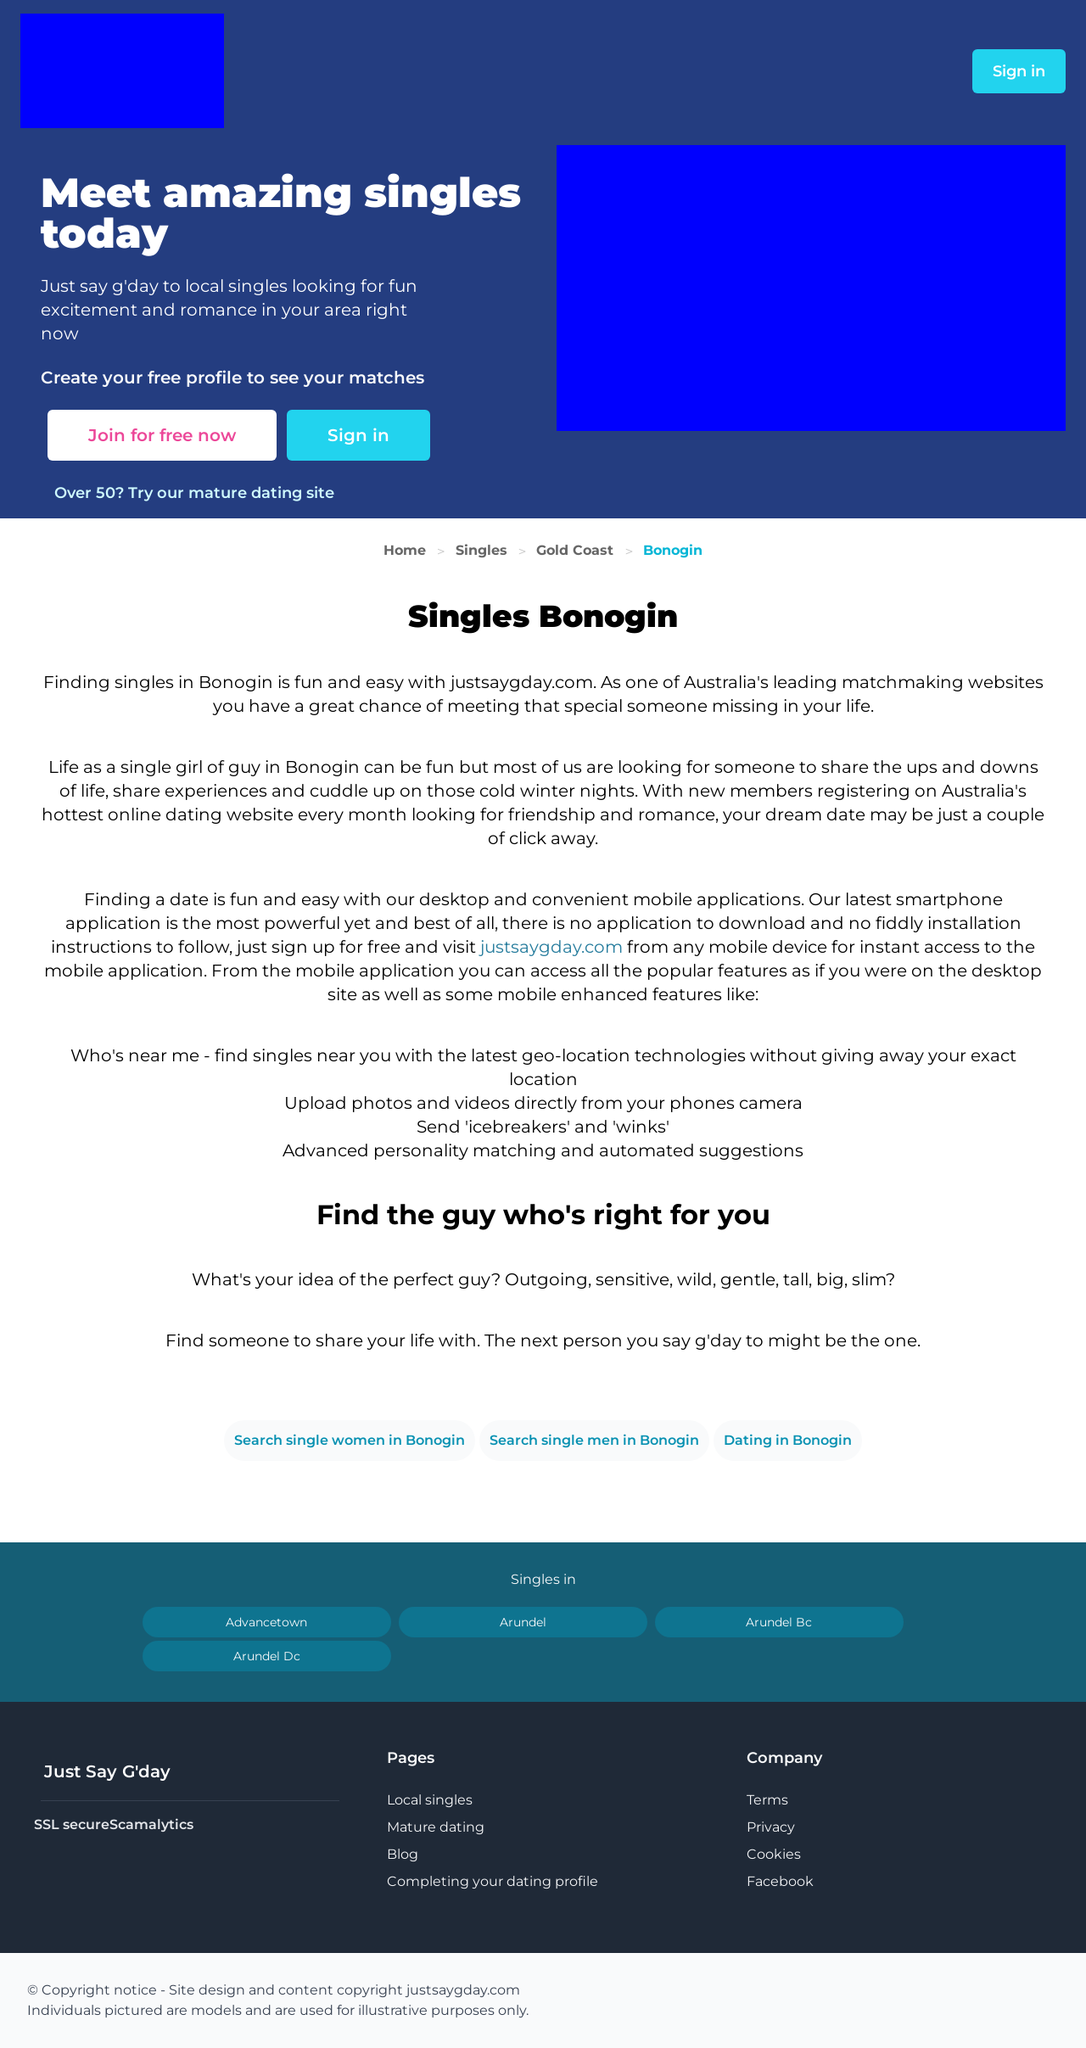Could you guide me through the process of developing this website with HTML? To start developing a website like the one shown in the image using HTML, you'll begin by setting up a basic structure with HTML tags such as <!DOCTYPE html>, <html>, <head>, and <body>. Inside the head, include meta tags for responsiveness and CSS links for styling. Use <div> tags to create sections like headers, main content areas, and footers. Apply CSS for styling or frameworks like Bootstrap for responsive design. Finally, test your website across different devices and browsers to ensure compatibility and usability. 